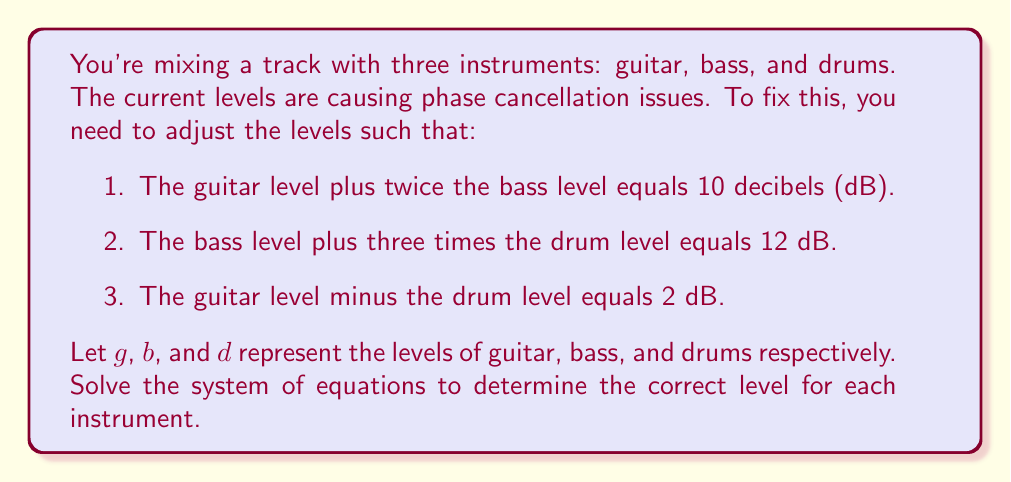Give your solution to this math problem. Let's solve this system of equations step by step:

1) First, let's write out our system of equations:

   $$\begin{cases}
   g + 2b = 10 \\
   b + 3d = 12 \\
   g - d = 2
   \end{cases}$$

2) From the third equation, we can express $g$ in terms of $d$:
   
   $$g = d + 2$$

3) Substitute this into the first equation:

   $$(d + 2) + 2b = 10$$
   $$d + 2b = 8$$

4) Now we have a system of two equations with two unknowns:

   $$\begin{cases}
   d + 2b = 8 \\
   b + 3d = 12
   \end{cases}$$

5) Multiply the first equation by 3 and the second by -1:

   $$\begin{cases}
   3d + 6b = 24 \\
   -b - 3d = -12
   \end{cases}$$

6) Add these equations:

   $$5b = 12$$

7) Solve for $b$:

   $$b = \frac{12}{5} = 2.4$$

8) Substitute this back into $b + 3d = 12$:

   $$2.4 + 3d = 12$$
   $$3d = 9.6$$
   $$d = 3.2$$

9) Finally, recall that $g = d + 2$:

   $$g = 3.2 + 2 = 5.2$$

Therefore, the levels should be set to:
Guitar (g): 5.2 dB
Bass (b): 2.4 dB
Drums (d): 3.2 dB
Answer: $g = 5.2$ dB, $b = 2.4$ dB, $d = 3.2$ dB 